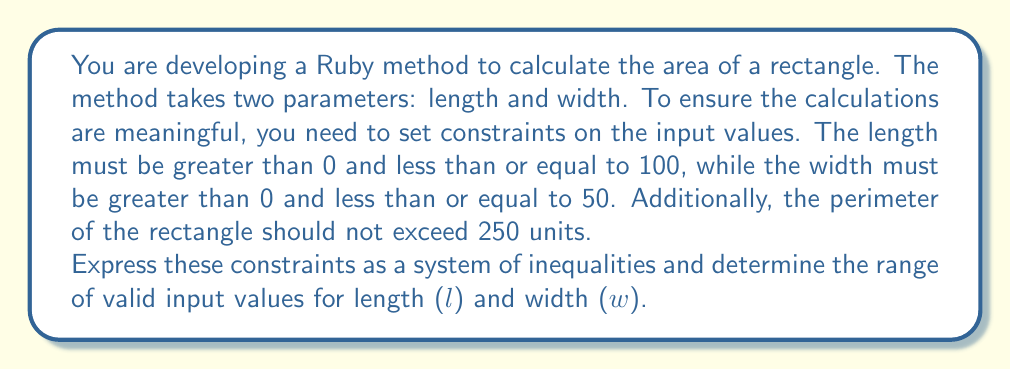Solve this math problem. Let's break this down step-by-step:

1. Constraints for length (l):
   $$ 0 < l \leq 100 $$

2. Constraints for width (w):
   $$ 0 < w \leq 50 $$

3. Perimeter constraint:
   The perimeter of a rectangle is given by $2l + 2w$. This should not exceed 250:
   $$ 2l + 2w \leq 250 $$
   Simplifying:
   $$ l + w \leq 125 $$

4. Combining all constraints:
   $$ \begin{cases}
      0 < l \leq 100 \\
      0 < w \leq 50 \\
      l + w \leq 125
   \end{cases} $$

5. To visualize this, we can plot these inequalities:

[asy]
import graph;
size(200);
xaxis("l", 0, 110, Arrow);
yaxis("w", 0, 60, Arrow);

draw((0,50)--(100,50), blue);
draw((100,0)--(100,50), blue);
draw((0,50)--(75,0), red);

label("w = 50", (50,52), N, blue);
label("l = 100", (102,25), E, blue);
label("l + w = 125", (50,40), NW, red);

fill((0,0)--(0,50)--(75,50)--(100,25)--(100,0)--cycle, lightgreen+opacity(0.2));
[/asy]

The shaded region represents the valid input values for l and w.

6. The range for l is from just above 0 to 100.
7. The range for w is from just above 0 to 50.
8. The additional constraint $l + w \leq 125$ further limits the upper bounds when one variable is near its maximum.
Answer: The range of valid input values is:

$$ \begin{cases}
   0 < l \leq 100 \\
   0 < w \leq 50 \\
   l + w \leq 125
\end{cases} $$

where l and w are real numbers satisfying all three inequalities simultaneously. 